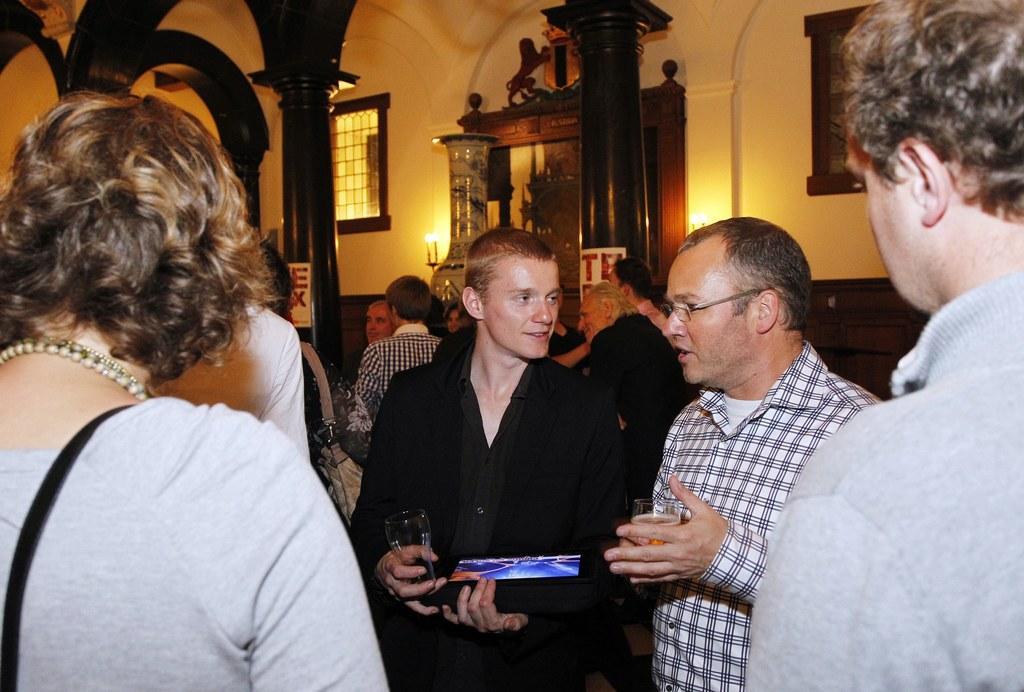Describe this image in one or two sentences. In this image, we can see persons wearing clothes. There are two persons holding glasses with their hands. There are pillars in the middle of the image. There is window at the top of the image. There is a photo frame in the top right of the image. 